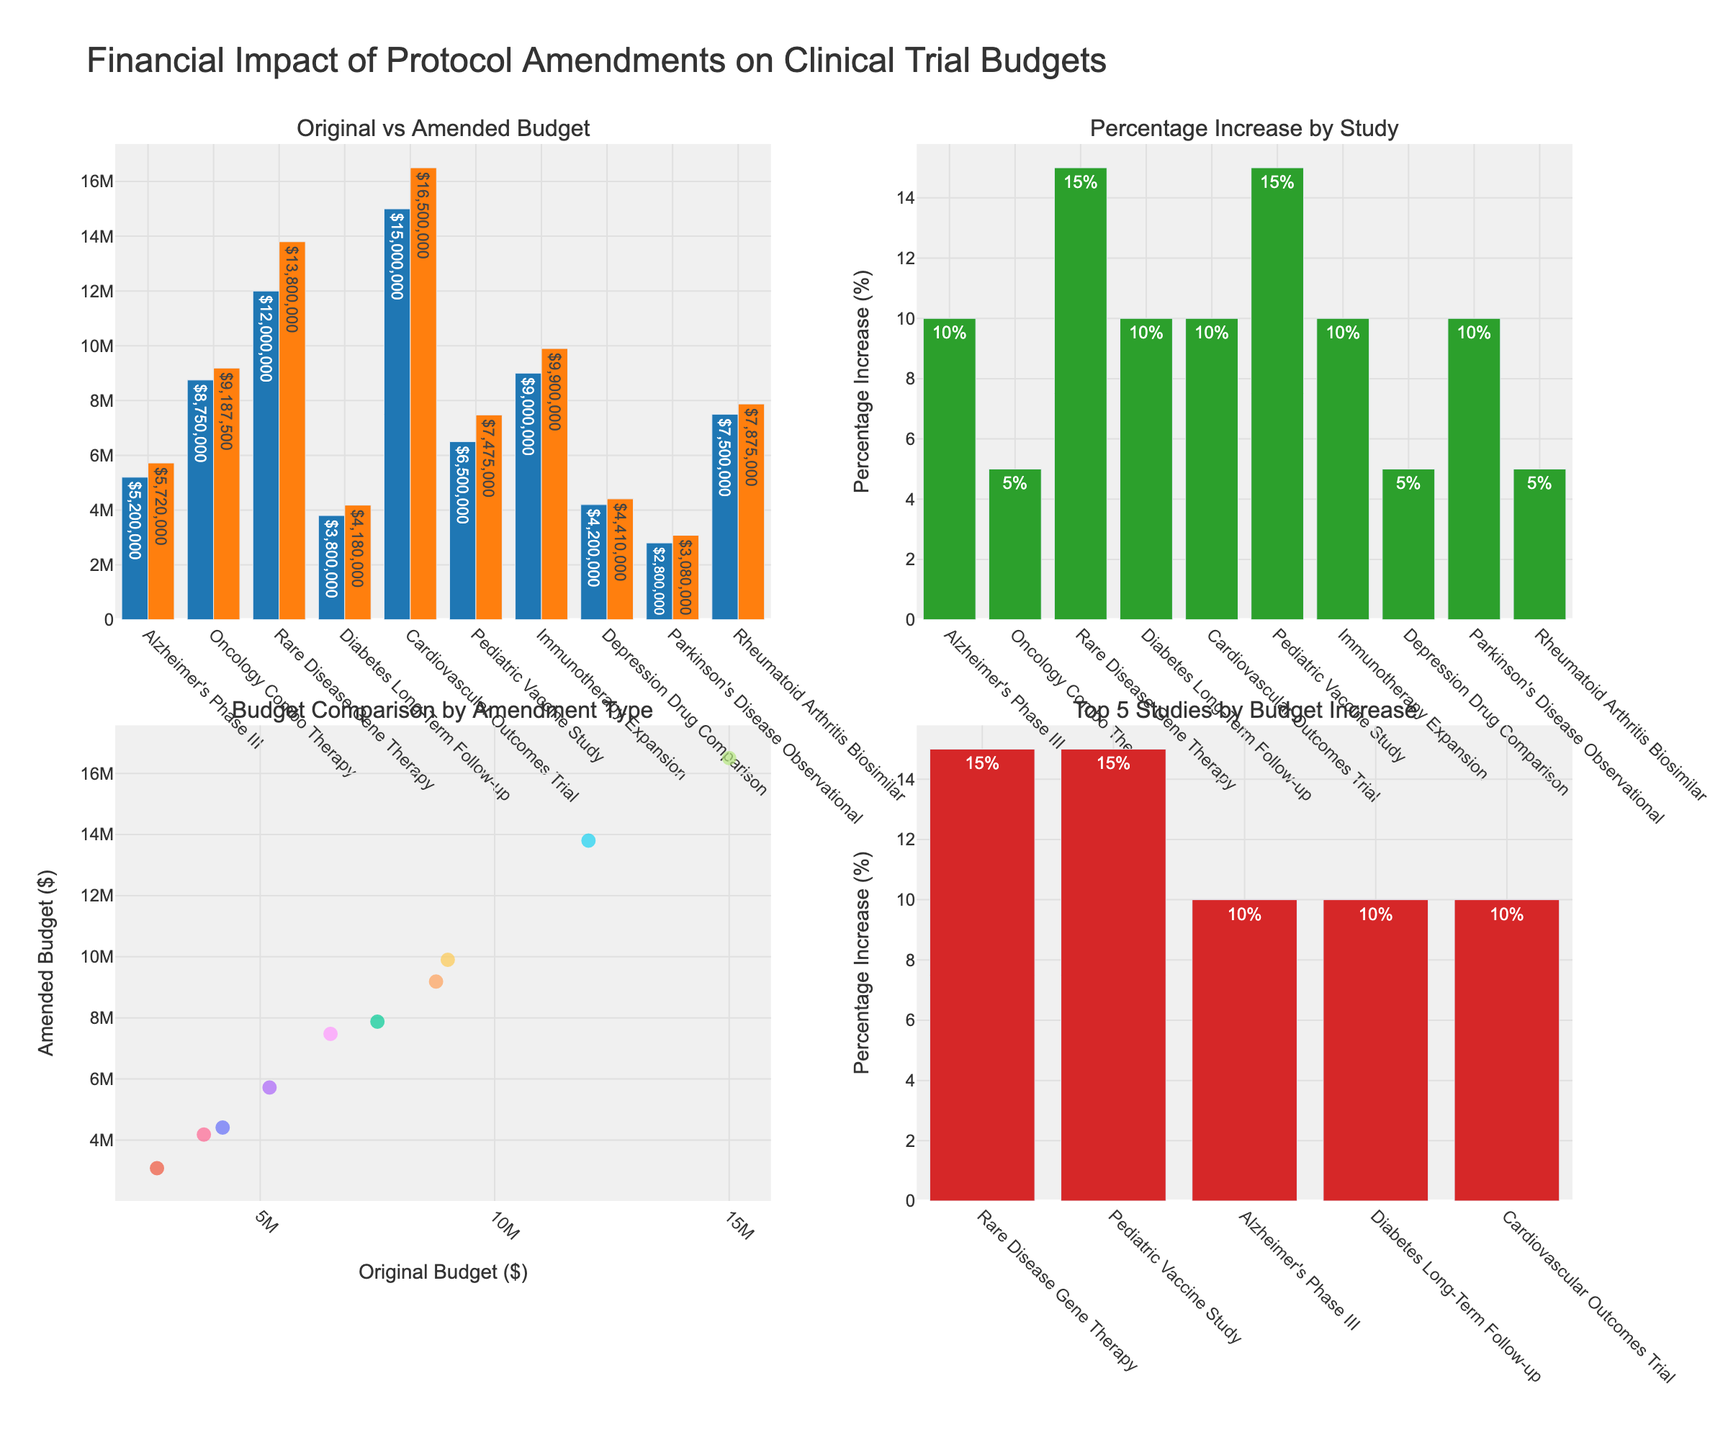What's the title of the figure? The figure's title is located at the top. It reads "Comparison of Student Participation Rates," which indicates the nature of the comparison being made within the plot.
Answer: Comparison of Student Participation Rates Which course has the highest participation rate in live sessions? Examine the heights of the bars in the Live Sessions subplot. The highest bar corresponds to 'Computer Science,' with a participation rate of 85%.
Answer: Computer Science Which course has the lowest participation rate in asynchronous activities? In the Asynchronous Activities subplot, look for the shortest bar, which represents 'Physical Education,' with a participation rate of 55%.
Answer: Physical Education What is the difference in participation rates between live sessions and asynchronous activities for Art? Compare the Art bars in both subplots. Live Sessions has a rate of 68%, and Asynchronous Activities has a rate of 88%. The difference is 88% - 68% = 20%.
Answer: 20% On average, do students participate more in live sessions or asynchronous activities in Mathematics, English Literature, and Biology? For each course, sum the participation rates for both live sessions and asynchronous activities, then divide by the number of courses:
Mathematics: (78 + 65) / 2 = 71.5
English Literature: (82 + 71) / 2 = 76.5
Biology: (75 + 80) / 2 = 77.5
The average for live sessions: (78 + 82 + 75) / 3 = 78.33
The average for asynchronous activities: (65 + 71 + 80) / 3 = 72.
Comparing 78.33 with 72, live sessions have a higher average participation rate.
Answer: Live sessions Which subplot contains the bar with the highest overall participation rate? Compare the heights of all bars in both subplots. The highest bar, representing 'Computer Science' with a rate of 90%, is in the Asynchronous Activities subplot.
Answer: Asynchronous Activities How many courses have higher participation rates in asynchronous activities compared to live sessions? Compare the heights of corresponding bars in both subplots for each course. Courses with higher rates in asynchronous are:
Biology (80 > 75), History (85 > 70), Computer Science (90 > 85), Chemistry (77 > 72), Art (88 > 68), and Physical Education (55 > 65), making it 6 courses in total.
Answer: 6 